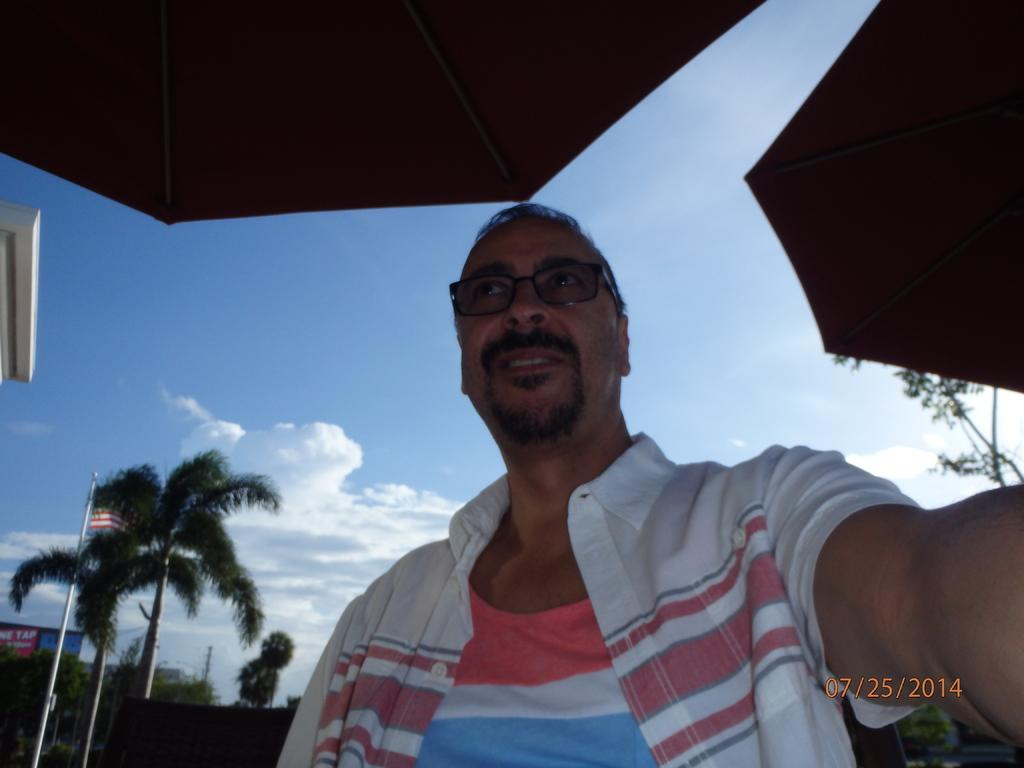Who is present in the image? There is a man in the image. What is the man wearing? The man is wearing spectacles. What objects are beside the man? There are umbrellas beside the man. What can be seen in the background of the image? There are trees, poles, and clouds visible in the background of the image. What type of fiction is the man reading in the image? There is no book or any indication of reading in the image, so it cannot be determined if the man is reading fiction or any other type of material. 